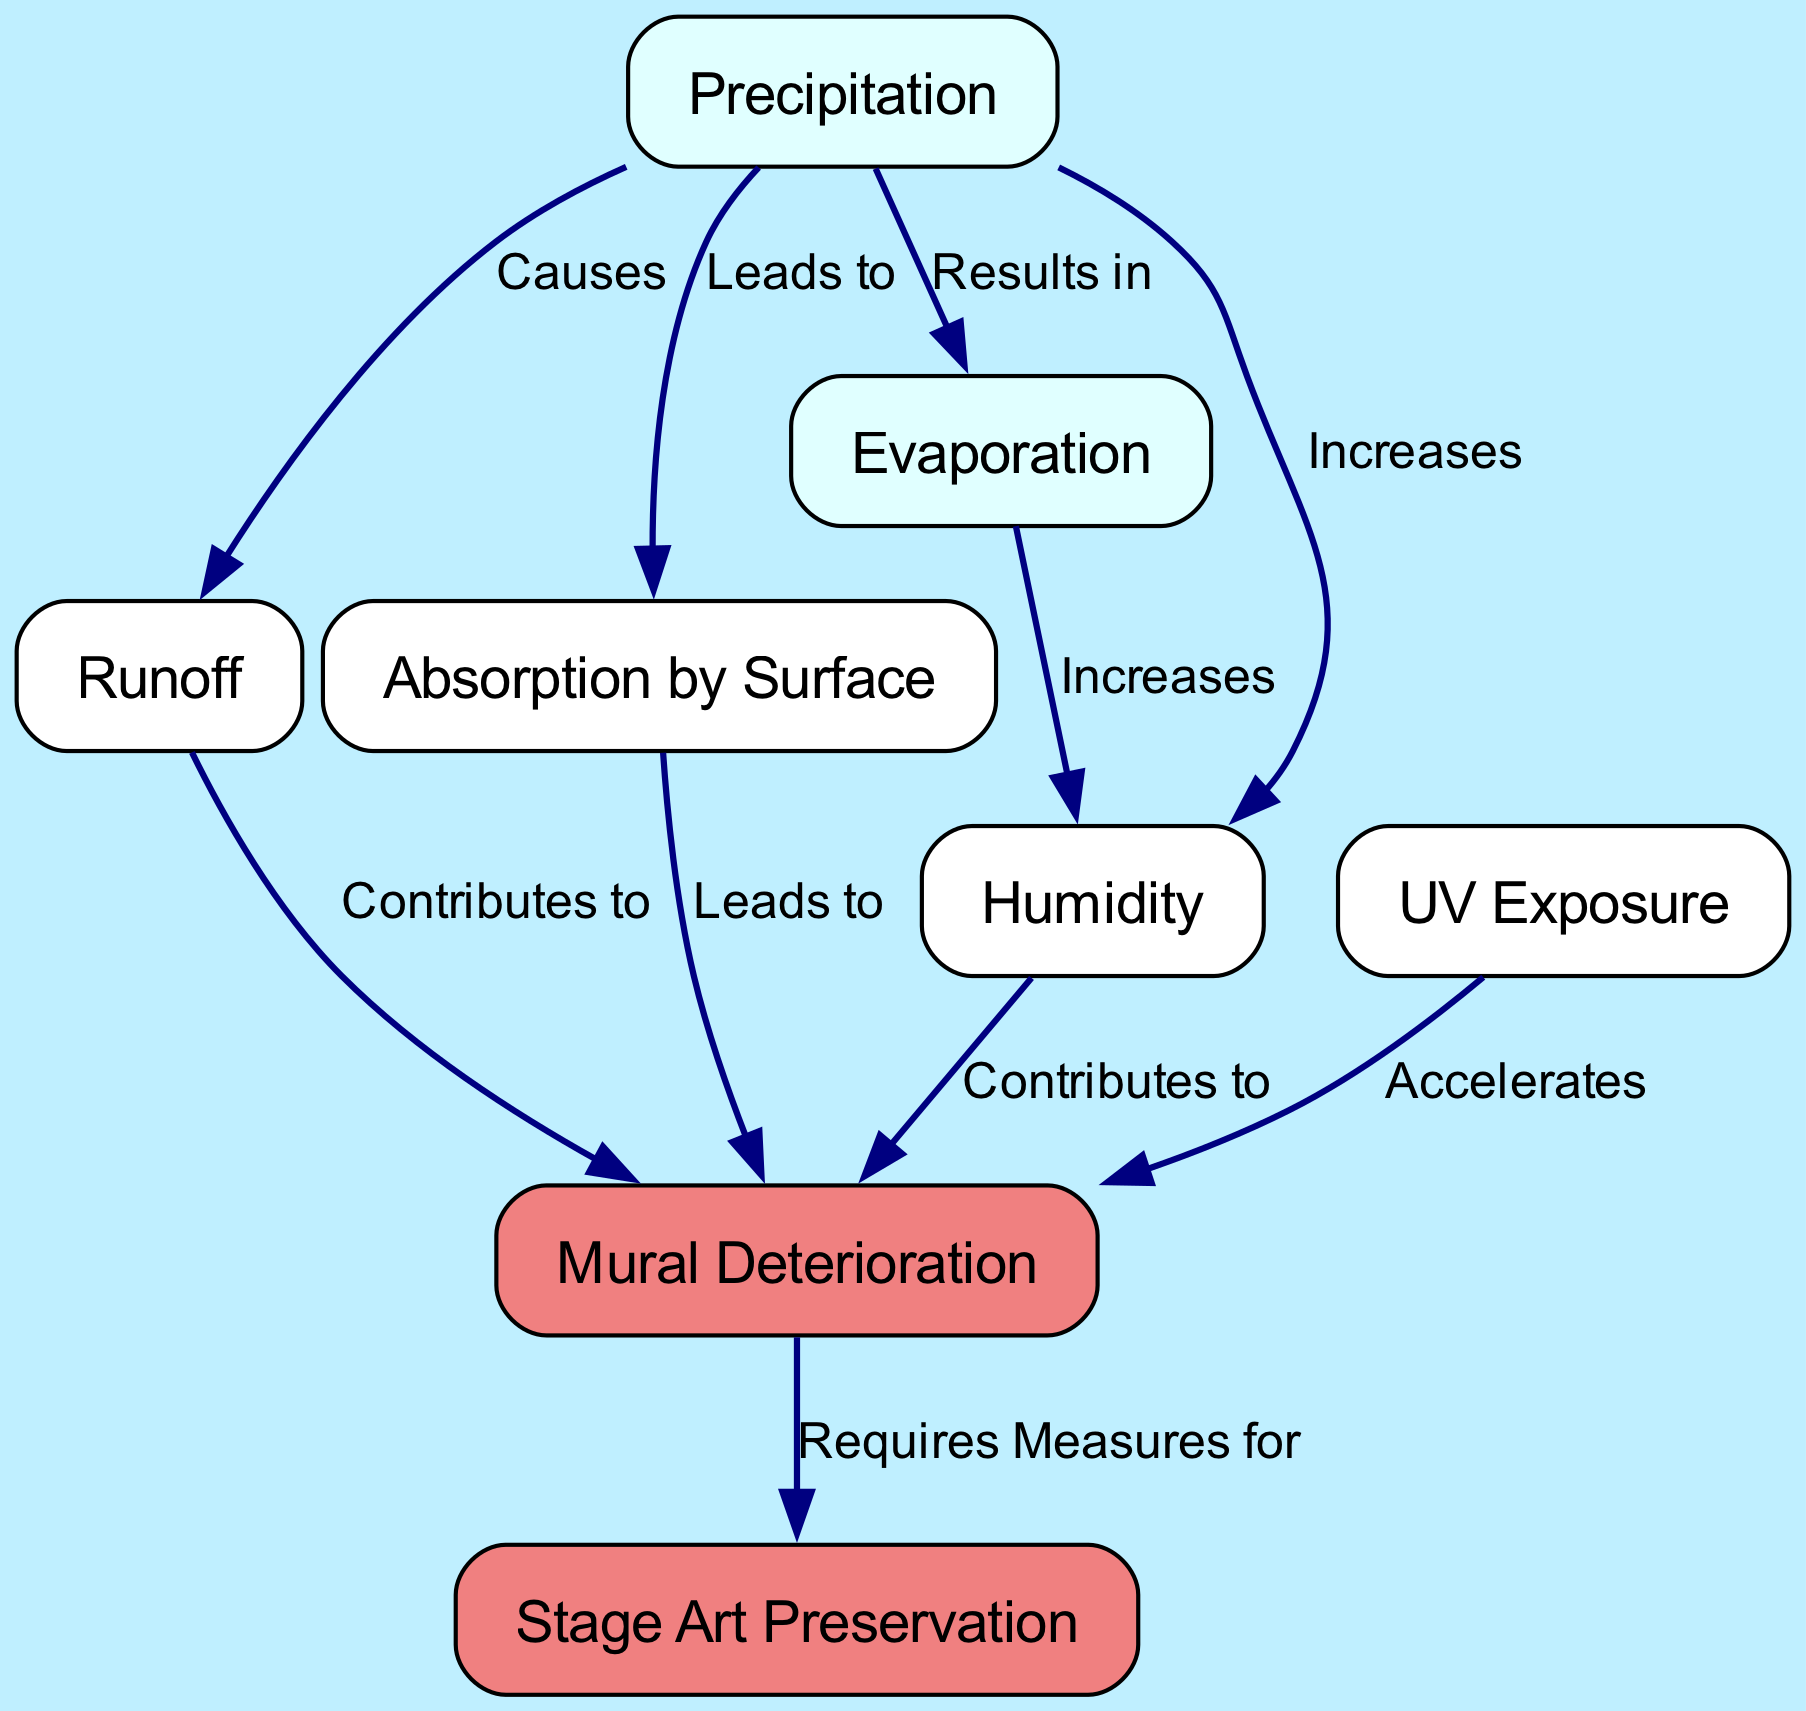What are the main nodes in the diagram? The main nodes listed in the diagram represent key elements of the water cycle and their influence on mural longevity. They are: Precipitation, Runoff, Absorption by Surface, Evaporation, Humidity, UV Exposure, Mural Deterioration, and Stage Art Preservation.
Answer: Precipitation, Runoff, Absorption by Surface, Evaporation, Humidity, UV Exposure, Mural Deterioration, Stage Art Preservation How many edges are present in the diagram? The diagram contains a total of 8 edges that represent the causal relationships between the nodes. Each edge illustrates how one element of the water cycle affects another aspect relevant to mural longevity.
Answer: 8 Which node is directly affected by Humidity? According to the diagram, Humidity has a direct connection contributing to Mural Deterioration, meaning it plays a role in the deterioration of murals.
Answer: Mural Deterioration What causes Evaporation according to the diagram? The diagram indicates that Evaporation results from Precipitation, highlighting the relationship between the amount of precipitation and the subsequent loss of water through evaporation in the cycle.
Answer: Precipitation Which relationship exemplifies a contributing factor to Mural Deterioration? The edges pointing from both Runoff and Absorption by Surface to Mural Deterioration exemplify factors that contribute to the deterioration of murals, according to the relationships defined in the diagram.
Answer: Runoff and Absorption by Surface What measure is required for Stage Art Preservation as indicated in the diagram? The diagram signifies that Mural Deterioration requires measures for Stage Art Preservation, suggesting that the deterioration of murals directly impacts the preservation strategies needed for stage art.
Answer: Measures for Stage Art Preservation How does UV Exposure influence Mural Deterioration? The influence of UV Exposure on Mural Deterioration is defined as an acceleration, indicating that UV light exposure increases the rate at which murals deteriorate.
Answer: Accelerates What increases as a result of Precipitation according to the diagram? The relationship established in the diagram shows that both Evaporation and Humidity increase as a result of Precipitation, indicating the interconnectedness of these elements in the water cycle.
Answer: Evaporation and Humidity 